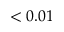<formula> <loc_0><loc_0><loc_500><loc_500>< 0 . 0 1</formula> 